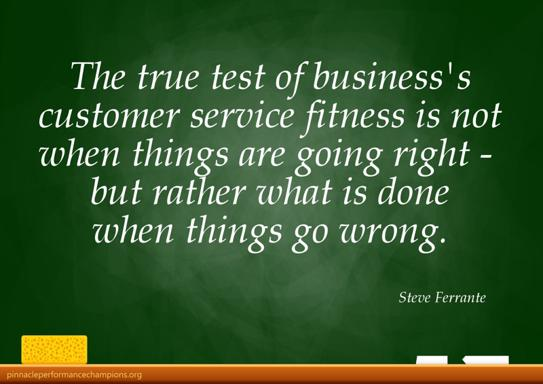What is the relevance of the chalkboard, chalk, and pencil in the image? The chalkboard, chalk, and pencil signify the traditional tools of learning, symbolizing that customer service too requires continuous education and adaptation. These elements remind viewers that effective customer service strategies are developed through constant learning, careful planning, and the flexibility to make real-time adjustments in response to customer needs and situations. 